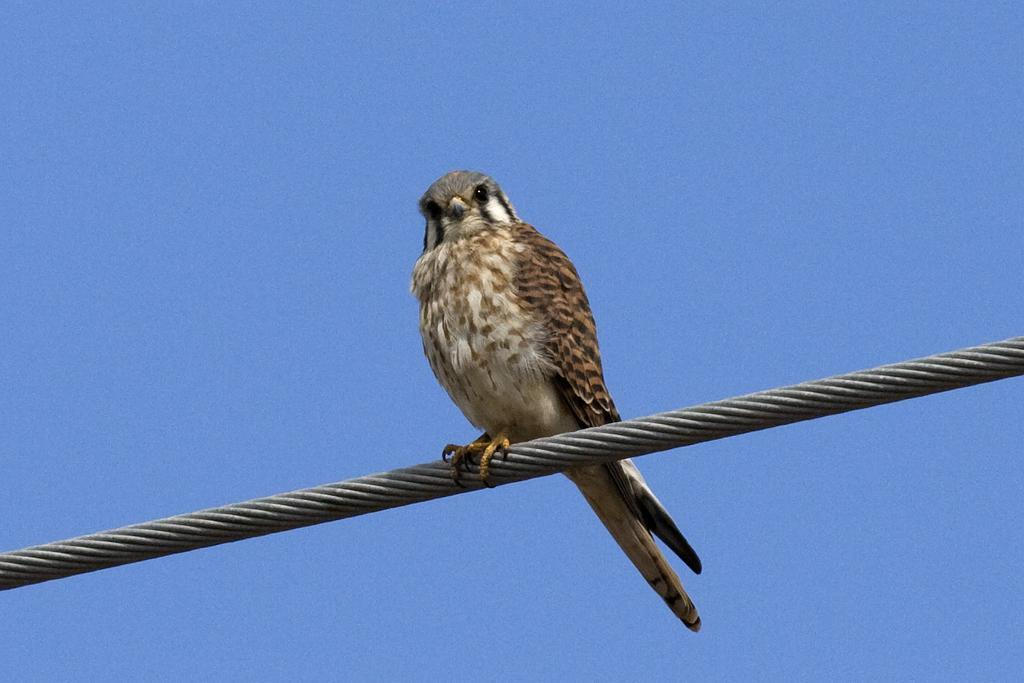What type of animal is present in the image? There is a brown color bird in the image. Where is the bird located in the image? The bird is sitting on an electric wire. What can be seen in the background of the image? There is a sky visible in the background of the image. What type of popcorn is the bird eating in the image? There is no popcorn present in the image, and the bird is not eating anything. What thought is the bird having while sitting on the electric wire? There is no indication of the bird's thoughts in the image, as we cannot determine its mental state from the image. 